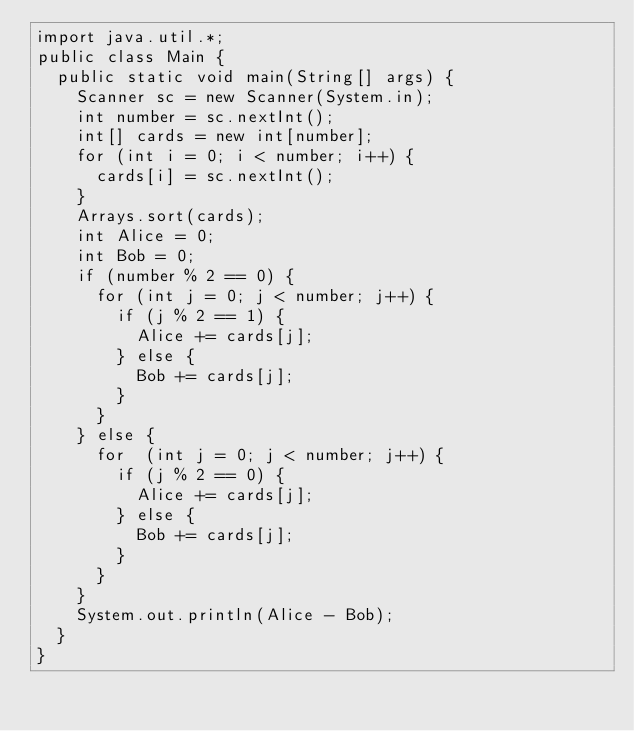Convert code to text. <code><loc_0><loc_0><loc_500><loc_500><_Java_>import java.util.*;
public class Main {
  public static void main(String[] args) {
    Scanner sc = new Scanner(System.in);
    int number = sc.nextInt();
    int[] cards = new int[number];
    for (int i = 0; i < number; i++) {
      cards[i] = sc.nextInt();
    }
    Arrays.sort(cards);
    int Alice = 0;
    int Bob = 0;
    if (number % 2 == 0) {
      for (int j = 0; j < number; j++) {
        if (j % 2 == 1) {
          Alice += cards[j];
        } else {
          Bob += cards[j];
        }
      }
    } else {
      for  (int j = 0; j < number; j++) {
        if (j % 2 == 0) {
          Alice += cards[j];
        } else {
          Bob += cards[j];
        }
      } 
    }
    System.out.println(Alice - Bob);
  }
}</code> 